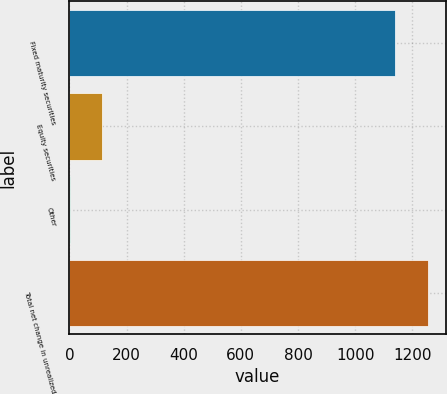Convert chart. <chart><loc_0><loc_0><loc_500><loc_500><bar_chart><fcel>Fixed maturity securities<fcel>Equity securities<fcel>Other<fcel>Total net change in unrealized<nl><fcel>1140<fcel>115.5<fcel>1<fcel>1254.5<nl></chart> 